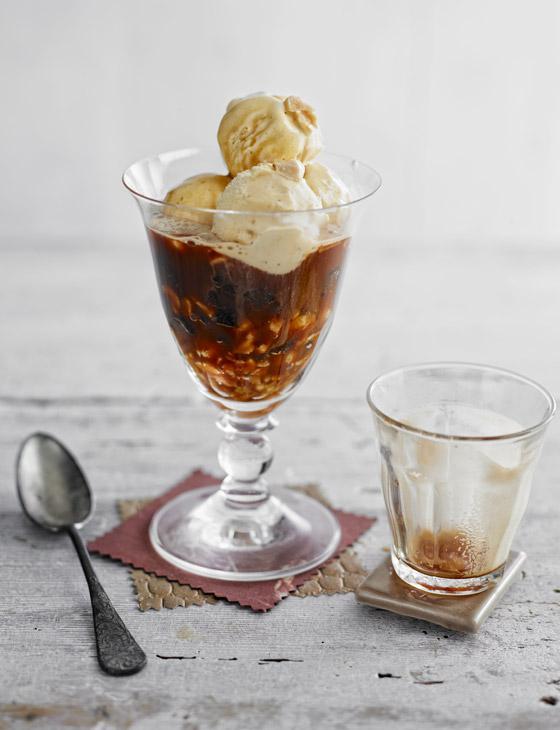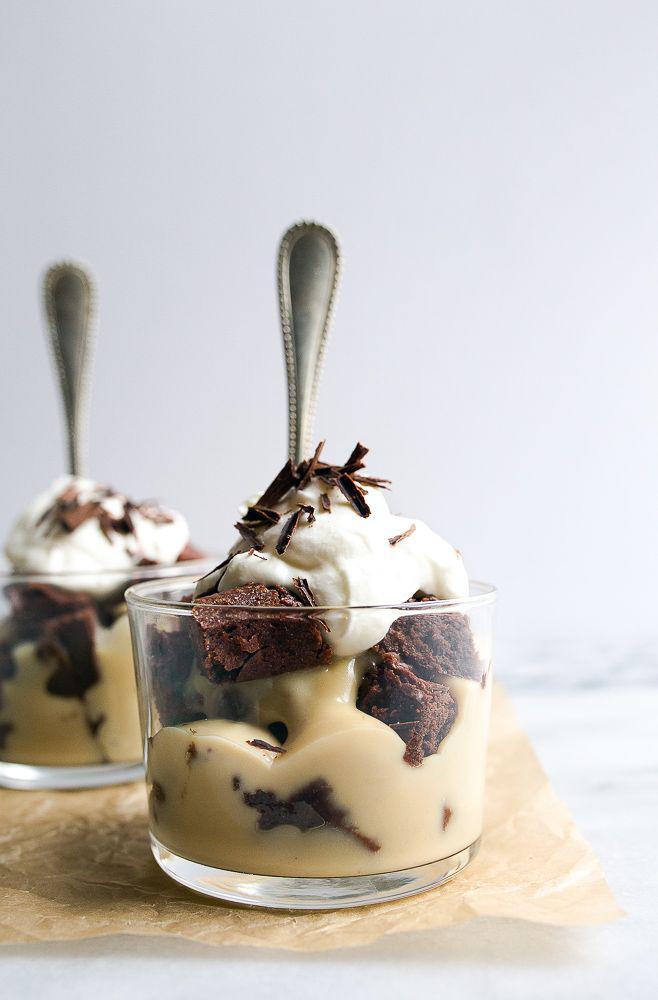The first image is the image on the left, the second image is the image on the right. Analyze the images presented: Is the assertion "There are two individual servings of desserts in the image on the left." valid? Answer yes or no. No. 